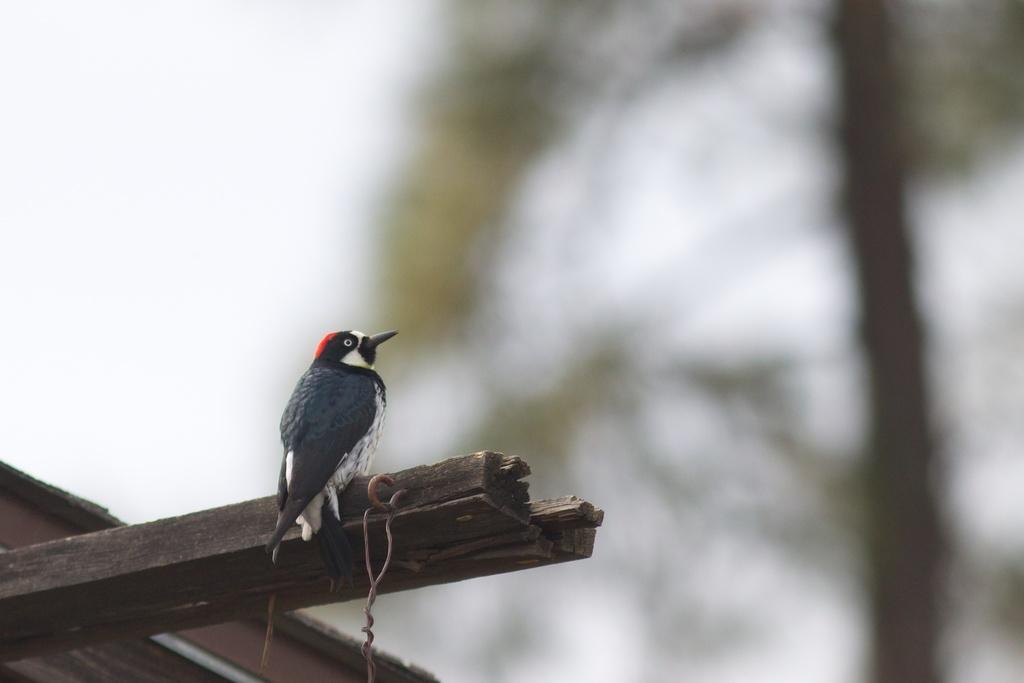Please provide a concise description of this image. In this image there is a bird on the wooden stick. 